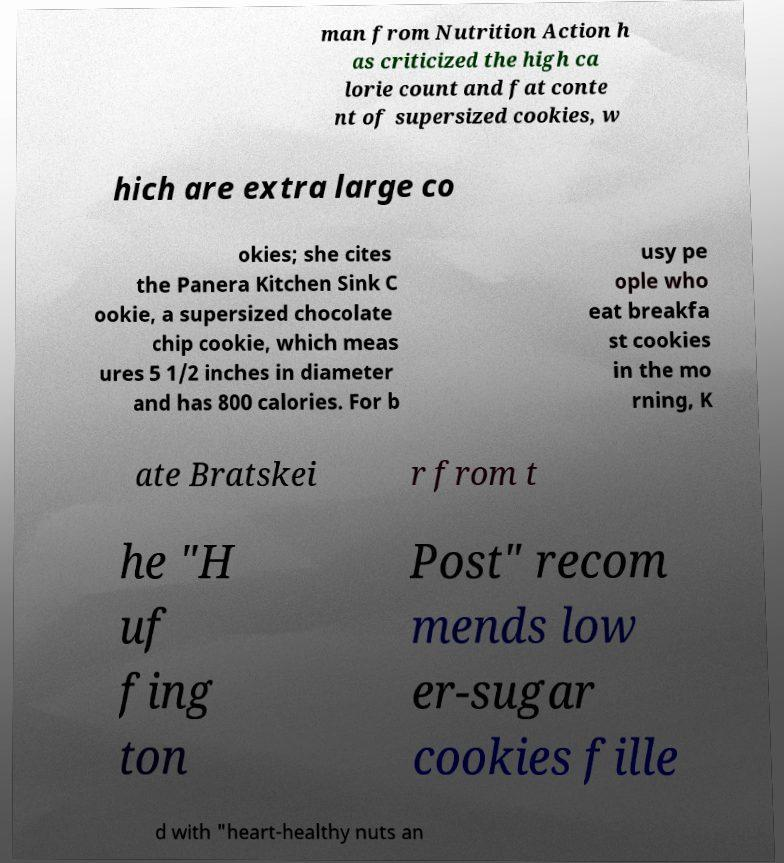What messages or text are displayed in this image? I need them in a readable, typed format. man from Nutrition Action h as criticized the high ca lorie count and fat conte nt of supersized cookies, w hich are extra large co okies; she cites the Panera Kitchen Sink C ookie, a supersized chocolate chip cookie, which meas ures 5 1/2 inches in diameter and has 800 calories. For b usy pe ople who eat breakfa st cookies in the mo rning, K ate Bratskei r from t he "H uf fing ton Post" recom mends low er-sugar cookies fille d with "heart-healthy nuts an 